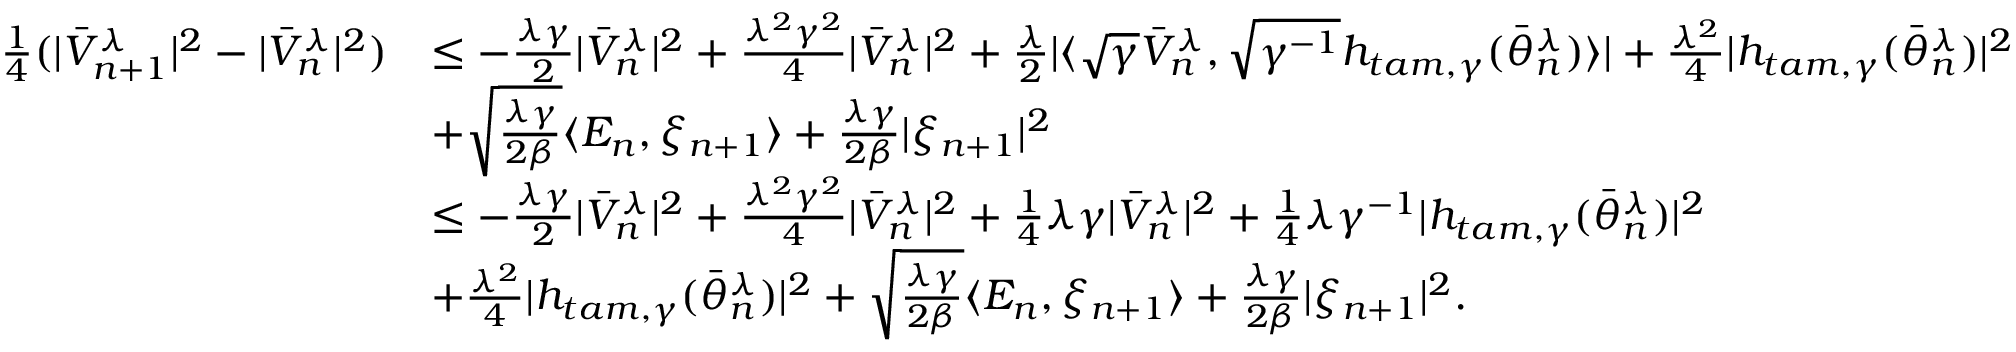Convert formula to latex. <formula><loc_0><loc_0><loc_500><loc_500>\begin{array} { r l } { \frac { 1 } { 4 } ( | \bar { V } _ { n + 1 } ^ { \lambda } | ^ { 2 } - | \bar { V } _ { n } ^ { \lambda } | ^ { 2 } ) } & { \leq - \frac { \lambda \gamma } { 2 } | \bar { V } _ { n } ^ { \lambda } | ^ { 2 } + \frac { \lambda ^ { 2 } \gamma ^ { 2 } } { 4 } | \bar { V } _ { n } ^ { \lambda } | ^ { 2 } + \frac { \lambda } { 2 } | \langle \sqrt { \gamma } \bar { V } _ { n } ^ { \lambda } , \sqrt { \gamma ^ { - 1 } } h _ { t a m , \gamma } ( \bar { \theta } _ { n } ^ { \lambda } ) \rangle | + \frac { \lambda ^ { 2 } } { 4 } | h _ { t a m , \gamma } ( \bar { \theta } _ { n } ^ { \lambda } ) | ^ { 2 } } \\ & { + \sqrt { \frac { \lambda \gamma } { 2 \beta } } \langle E _ { n } , \xi _ { n + 1 } \rangle + \frac { \lambda \gamma } { 2 \beta } | \xi _ { n + 1 } | ^ { 2 } } \\ & { \leq - \frac { \lambda \gamma } { 2 } | \bar { V } _ { n } ^ { \lambda } | ^ { 2 } + \frac { \lambda ^ { 2 } \gamma ^ { 2 } } { 4 } | \bar { V } _ { n } ^ { \lambda } | ^ { 2 } + \frac { 1 } { 4 } \lambda \gamma | \bar { V } _ { n } ^ { \lambda } | ^ { 2 } + \frac { 1 } { 4 } \lambda \gamma ^ { - 1 } | h _ { t a m , \gamma } ( \bar { \theta } _ { n } ^ { \lambda } ) | ^ { 2 } } \\ & { + \frac { \lambda ^ { 2 } } { 4 } | h _ { t a m , \gamma } ( \bar { \theta } _ { n } ^ { \lambda } ) | ^ { 2 } + \sqrt { \frac { \lambda \gamma } { 2 \beta } } \langle E _ { n } , \xi _ { n + 1 } \rangle + \frac { \lambda \gamma } { 2 \beta } | \xi _ { n + 1 } | ^ { 2 } . } \end{array}</formula> 